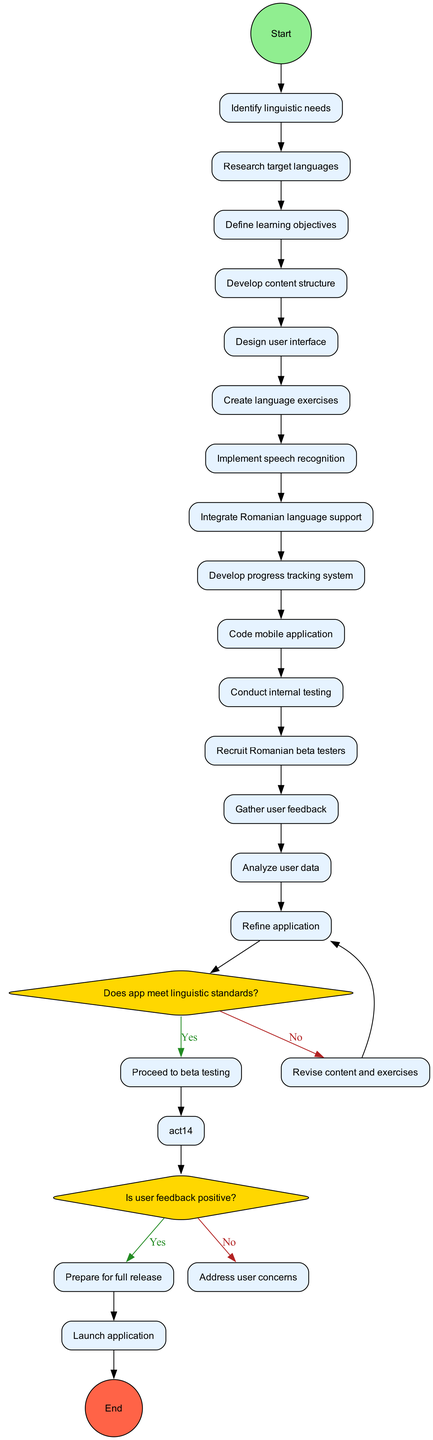What is the first activity in the workflow? The start node leads to the first activity, which is "Identify linguistic needs."
Answer: Identify linguistic needs How many decision points are there in the diagram? There are two decision points based on the conditions presented for proceeding with the workflow.
Answer: 2 What happens if the app does not meet linguistic standards? If the app fails to meet linguistic standards, the flow indicates a return to "Revise content and exercises."
Answer: Revise content and exercises What is the last activity before the application is launched? The last activity before launching is "Refine application," which leads directly to the end node labeled "Launch application."
Answer: Refine application If user feedback is positive, what is the next step in the workflow? If user feedback is positive, the diagram indicates that the next step is to "Prepare for full release."
Answer: Prepare for full release Which activity comes directly before "Conduct internal testing"? "Code mobile application" is the activity that comes immediately before "Conduct internal testing" in the workflow.
Answer: Code mobile application What condition is checked after internal testing? The condition checked after internal testing is whether the app meets linguistic standards.
Answer: Does app meet linguistic standards? What does the decision flow indicate if user feedback is negative? If user feedback is negative, the flow directs to "Address user concerns," indicating a need to respond to issues.
Answer: Address user concerns 